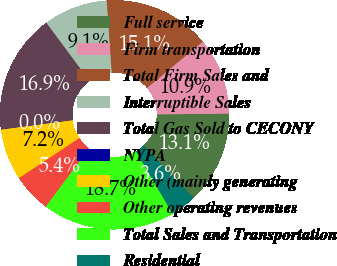Convert chart to OTSL. <chart><loc_0><loc_0><loc_500><loc_500><pie_chart><fcel>Full service<fcel>Firm transportation<fcel>Total Firm Sales and<fcel>Interruptible Sales<fcel>Total Gas Sold to CECONY<fcel>NYPA<fcel>Other (mainly generating<fcel>Other operating revenues<fcel>Total Sales and Transportation<fcel>Residential<nl><fcel>13.09%<fcel>10.86%<fcel>15.07%<fcel>9.05%<fcel>16.87%<fcel>0.04%<fcel>7.25%<fcel>5.45%<fcel>18.68%<fcel>3.64%<nl></chart> 